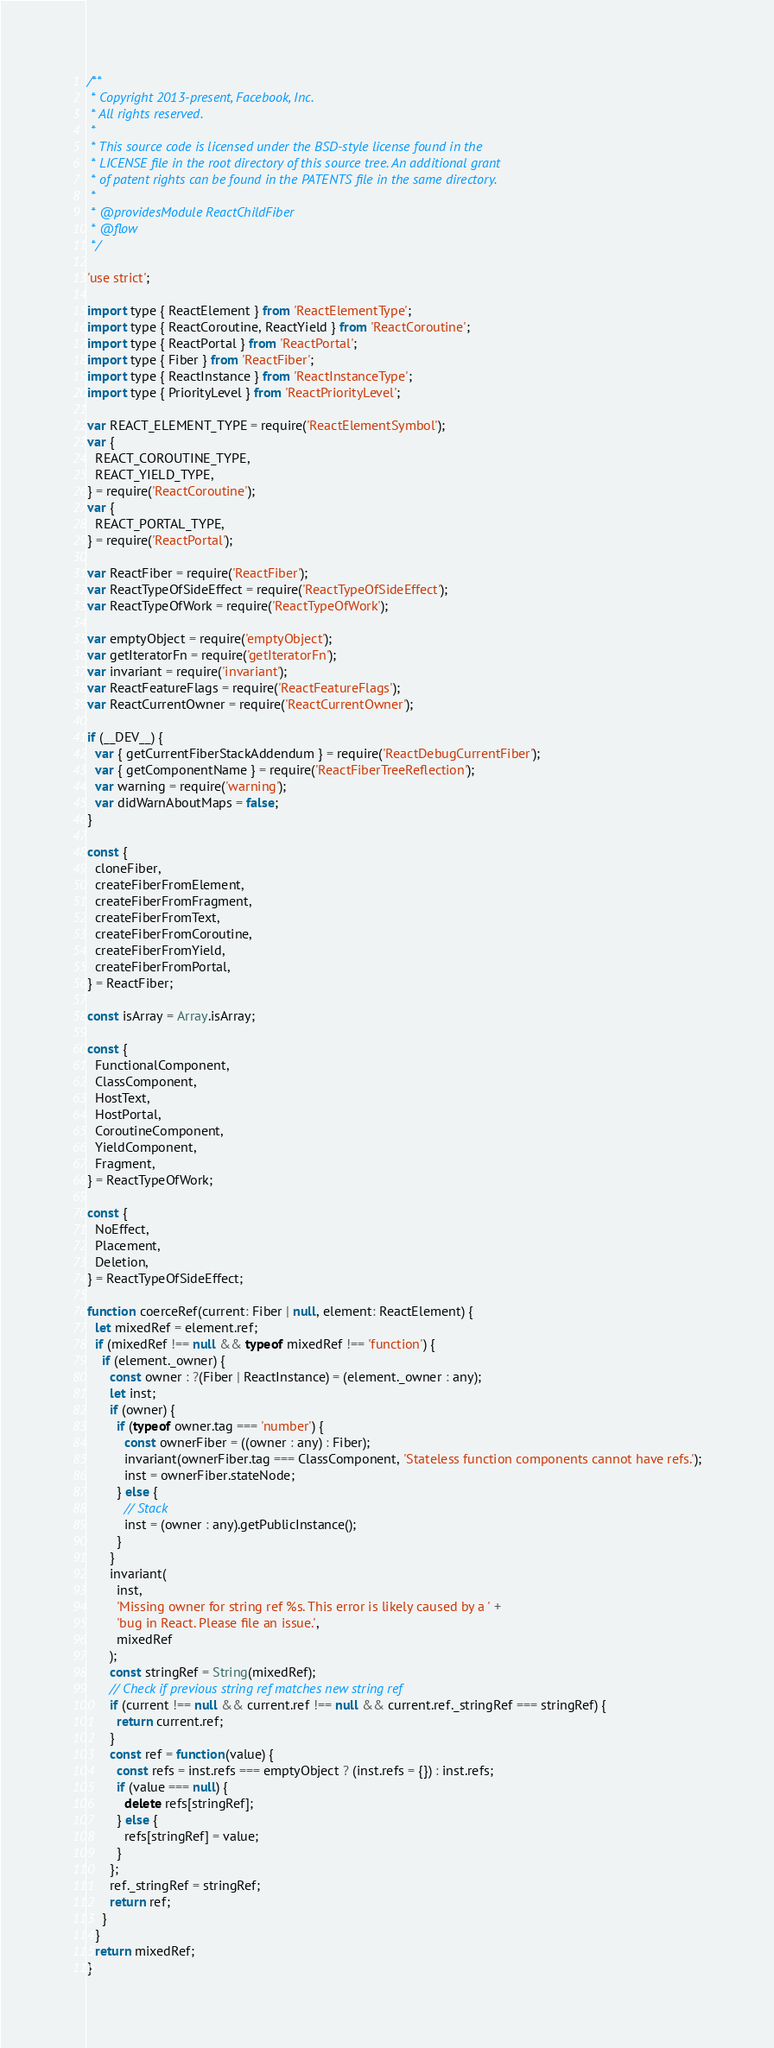<code> <loc_0><loc_0><loc_500><loc_500><_JavaScript_>/**
 * Copyright 2013-present, Facebook, Inc.
 * All rights reserved.
 *
 * This source code is licensed under the BSD-style license found in the
 * LICENSE file in the root directory of this source tree. An additional grant
 * of patent rights can be found in the PATENTS file in the same directory.
 *
 * @providesModule ReactChildFiber
 * @flow
 */

'use strict';

import type { ReactElement } from 'ReactElementType';
import type { ReactCoroutine, ReactYield } from 'ReactCoroutine';
import type { ReactPortal } from 'ReactPortal';
import type { Fiber } from 'ReactFiber';
import type { ReactInstance } from 'ReactInstanceType';
import type { PriorityLevel } from 'ReactPriorityLevel';

var REACT_ELEMENT_TYPE = require('ReactElementSymbol');
var {
  REACT_COROUTINE_TYPE,
  REACT_YIELD_TYPE,
} = require('ReactCoroutine');
var {
  REACT_PORTAL_TYPE,
} = require('ReactPortal');

var ReactFiber = require('ReactFiber');
var ReactTypeOfSideEffect = require('ReactTypeOfSideEffect');
var ReactTypeOfWork = require('ReactTypeOfWork');

var emptyObject = require('emptyObject');
var getIteratorFn = require('getIteratorFn');
var invariant = require('invariant');
var ReactFeatureFlags = require('ReactFeatureFlags');
var ReactCurrentOwner = require('ReactCurrentOwner');

if (__DEV__) {
  var { getCurrentFiberStackAddendum } = require('ReactDebugCurrentFiber');
  var { getComponentName } = require('ReactFiberTreeReflection');
  var warning = require('warning');
  var didWarnAboutMaps = false;
}

const {
  cloneFiber,
  createFiberFromElement,
  createFiberFromFragment,
  createFiberFromText,
  createFiberFromCoroutine,
  createFiberFromYield,
  createFiberFromPortal,
} = ReactFiber;

const isArray = Array.isArray;

const {
  FunctionalComponent,
  ClassComponent,
  HostText,
  HostPortal,
  CoroutineComponent,
  YieldComponent,
  Fragment,
} = ReactTypeOfWork;

const {
  NoEffect,
  Placement,
  Deletion,
} = ReactTypeOfSideEffect;

function coerceRef(current: Fiber | null, element: ReactElement) {
  let mixedRef = element.ref;
  if (mixedRef !== null && typeof mixedRef !== 'function') {
    if (element._owner) {
      const owner : ?(Fiber | ReactInstance) = (element._owner : any);
      let inst;
      if (owner) {
        if (typeof owner.tag === 'number') {
          const ownerFiber = ((owner : any) : Fiber);
          invariant(ownerFiber.tag === ClassComponent, 'Stateless function components cannot have refs.');
          inst = ownerFiber.stateNode;
        } else {
          // Stack
          inst = (owner : any).getPublicInstance();
        }
      }
      invariant(
        inst,
        'Missing owner for string ref %s. This error is likely caused by a ' +
        'bug in React. Please file an issue.',
        mixedRef
      );
      const stringRef = String(mixedRef);
      // Check if previous string ref matches new string ref
      if (current !== null && current.ref !== null && current.ref._stringRef === stringRef) {
        return current.ref;
      }
      const ref = function(value) {
        const refs = inst.refs === emptyObject ? (inst.refs = {}) : inst.refs;
        if (value === null) {
          delete refs[stringRef];
        } else {
          refs[stringRef] = value;
        }
      };
      ref._stringRef = stringRef;
      return ref;
    }
  }
  return mixedRef;
}
</code> 